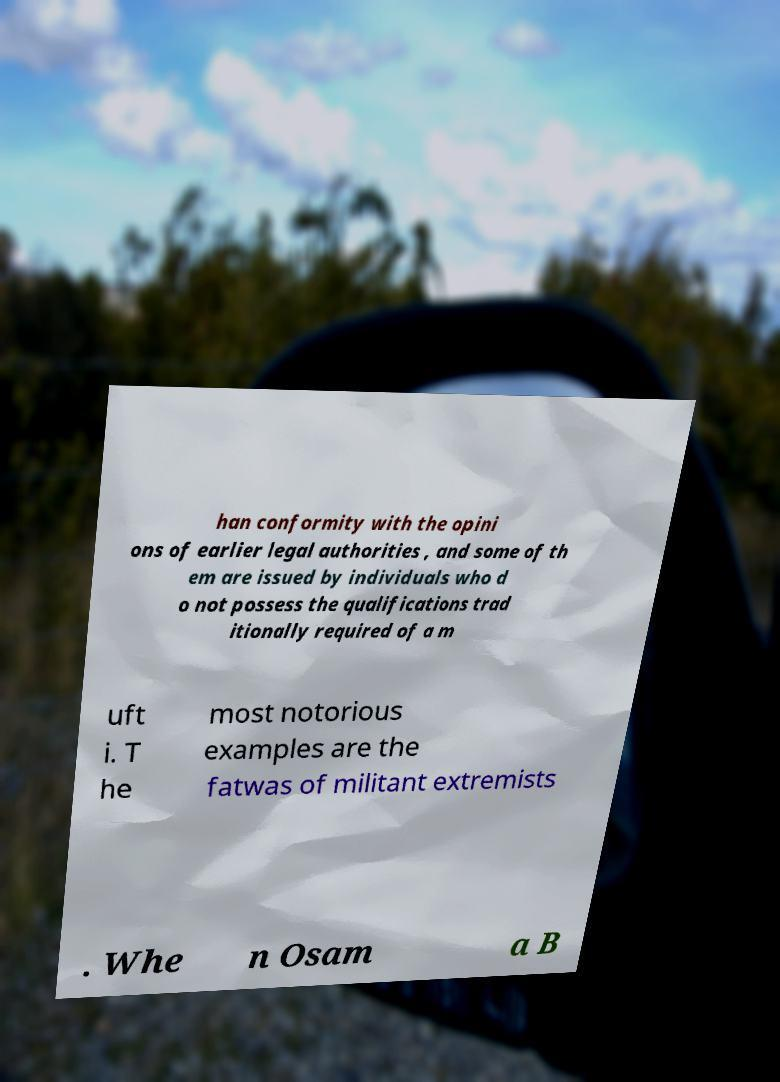I need the written content from this picture converted into text. Can you do that? han conformity with the opini ons of earlier legal authorities , and some of th em are issued by individuals who d o not possess the qualifications trad itionally required of a m uft i. T he most notorious examples are the fatwas of militant extremists . Whe n Osam a B 